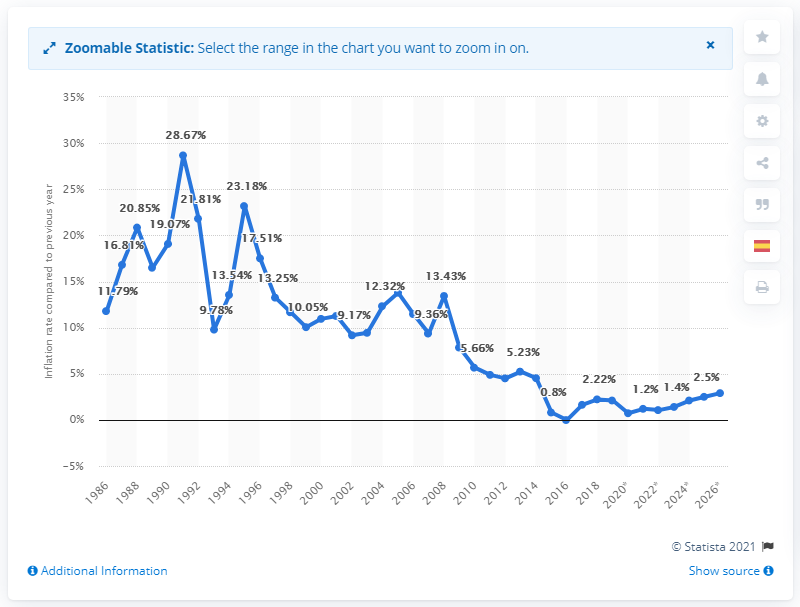Draw attention to some important aspects in this diagram. In 2019, the inflation rate in Costa Rica was 2.1%. 